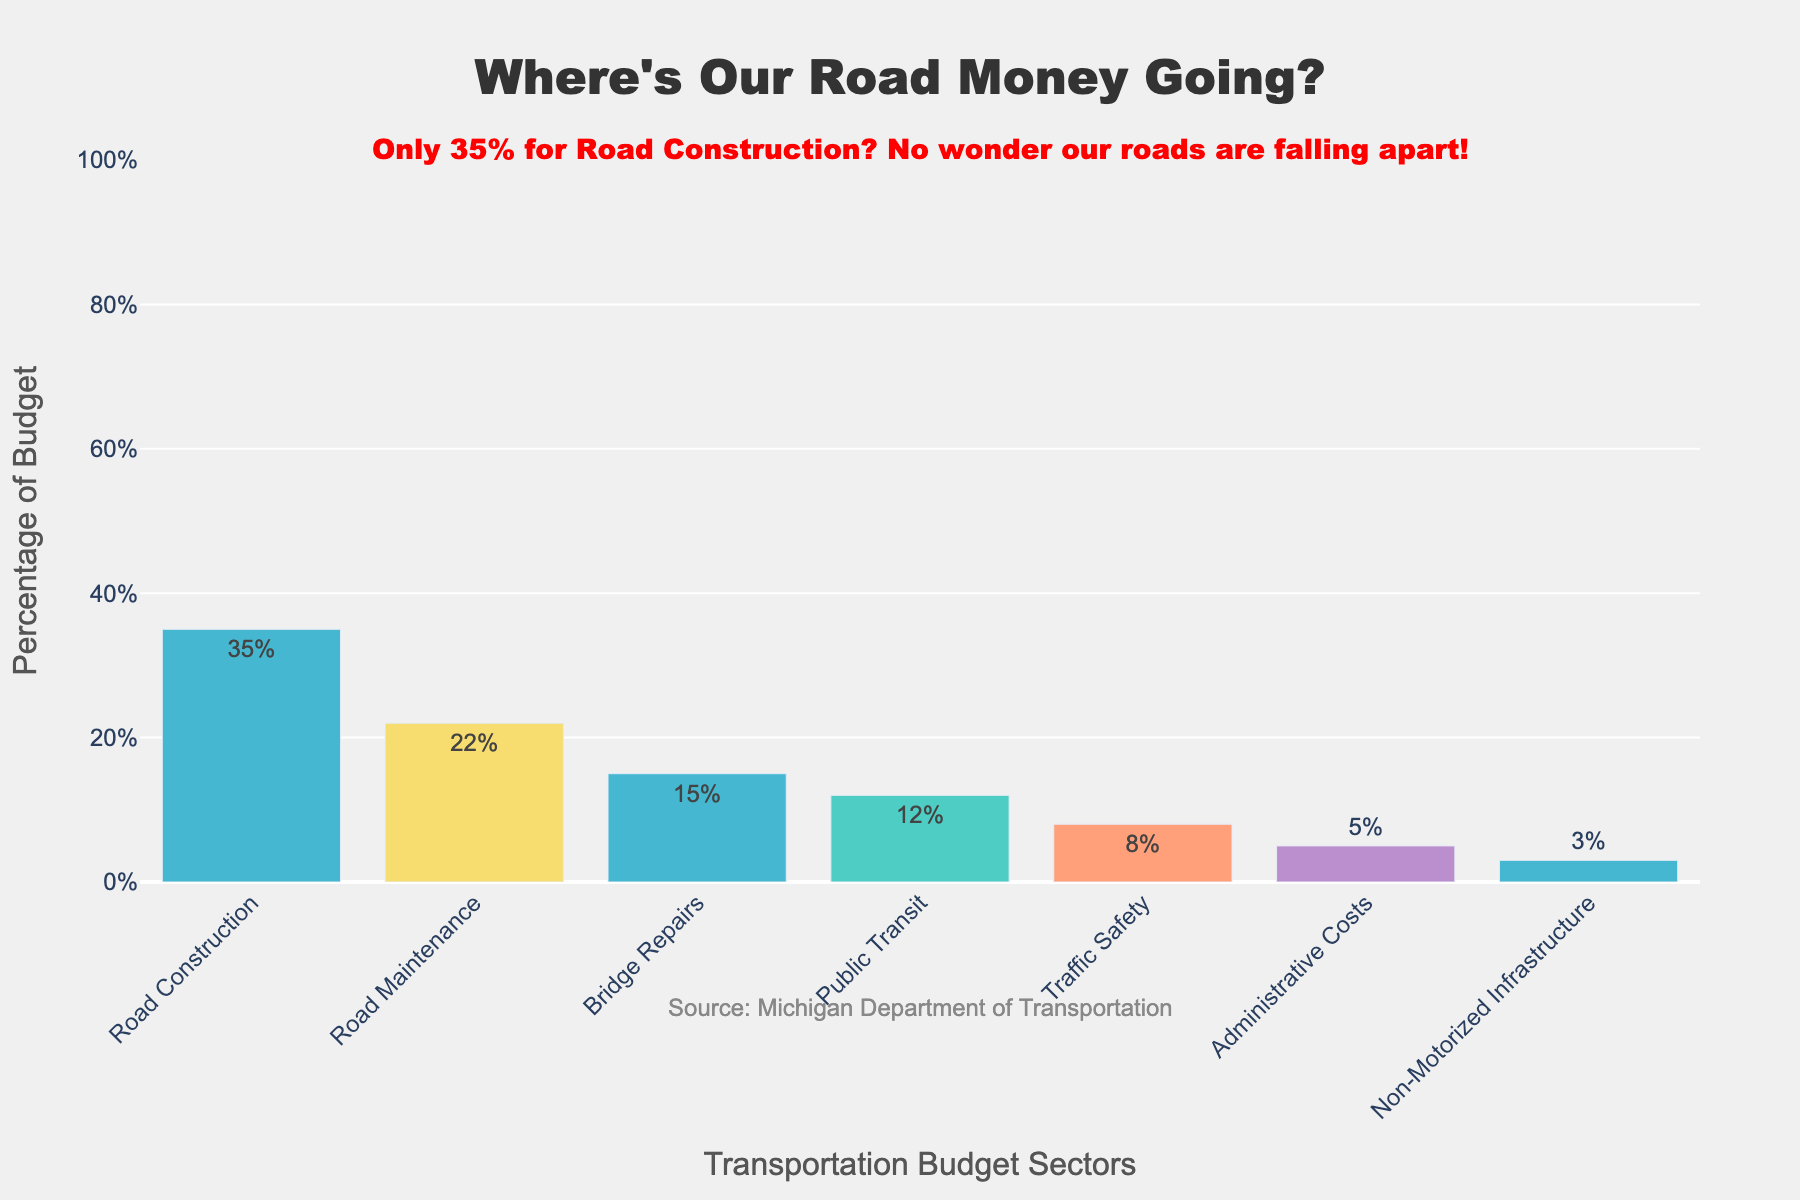Which sector receives the highest percentage of the transportation budget? The sector with the highest percentage is represented by the tallest bar, which is labeled "Road Construction" with 35%.
Answer: Road Construction What's the difference between the percentage allocated to Traffic Safety and Non-Motorized Infrastructure? The percentage for Traffic Safety is 8% and for Non-Motorized Infrastructure is 3%. The difference is 8% - 3% = 5%.
Answer: 5% What percentage of the budget is spent on Public Transit and Administrative Costs combined? The percentage for Public Transit is 12% and Administrative Costs is 5%. Combined, it's 12% + 5% = 17%.
Answer: 17% Is the budget for Road Construction greater than the combined budget for Road Maintenance and Bridge Repairs? The budget for Road Construction is 35%. Combining Road Maintenance (22%) and Bridge Repairs (15%) gives 22% + 15% = 37%. Road Construction's budget is less.
Answer: No Which sector has the second-lowest percentage in the budget? The sectors and their percentages are listed, and the second-lowest after Non-Motorized Infrastructure (3%) is Administrative Costs at 5%.
Answer: Administrative Costs What is the total percentage of the budget allocated to Road Construction, Road Maintenance, and Bridge Repairs? Summing the percentages of these sectors: 35% (Road Construction) + 22% (Road Maintenance) + 15% (Bridge Repairs) = 72%.
Answer: 72% Which receives a higher budget, Public Transit or Traffic Safety, and by how much? Public Transit is 12% and Traffic Safety is 8%. The difference is 12% - 8% = 4%.
Answer: Public Transit by 4% How does the budget for Road Maintenance compare to the budget for Administrative Costs? Road Maintenance has a budget of 22%, while Administrative Costs have 5%. Road Maintenance's percentage is higher.
Answer: Road Maintenance If the budget for Non-Motorized Infrastructure were doubled, what would its new percentage be? The current percentage for Non-Motorized Infrastructure is 3%. Doubling it would result in 3% * 2 = 6%.
Answer: 6% What is the average percentage allocated to Traffic Safety and Non-Motorized Infrastructure? Sum the percentages of Traffic Safety (8%) and Non-Motorized Infrastructure (3%) to get 11%. Dividing by 2 for the average: 11% / 2 = 5.5%.
Answer: 5.5% 